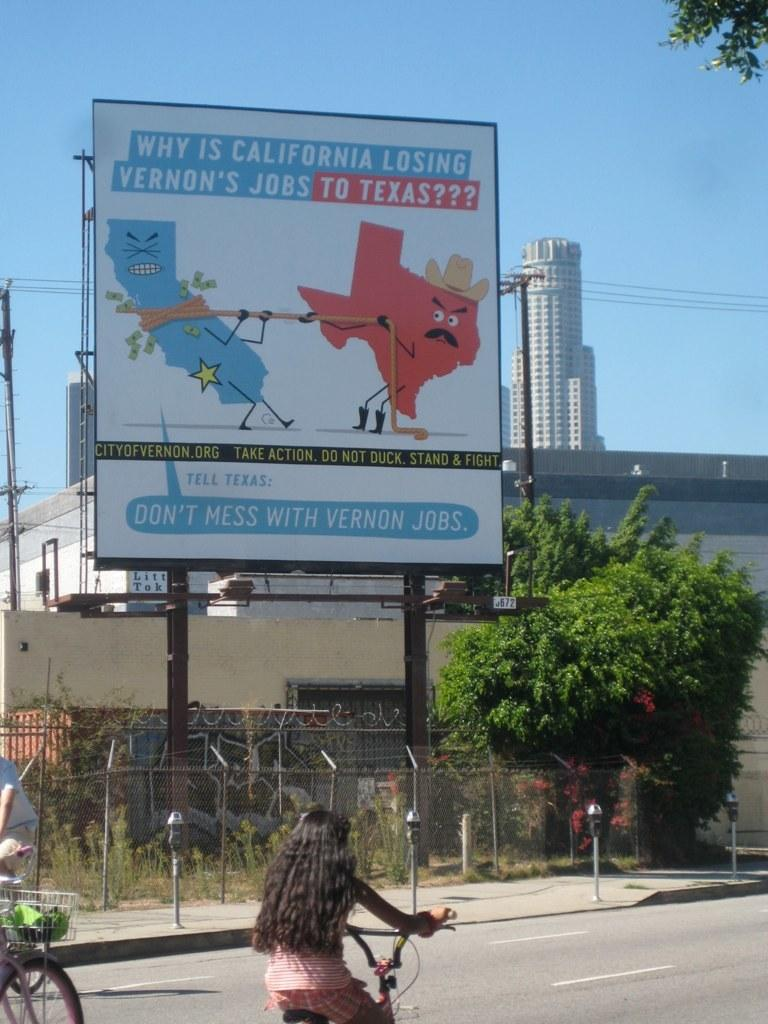<image>
Summarize the visual content of the image. A billboard about Vernon jobs shows cartoons of the states of California and Texas. 